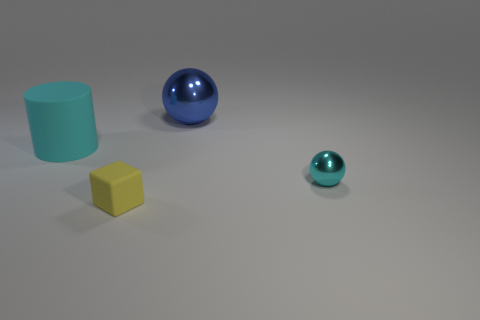There is a object that is right of the yellow rubber object and in front of the big shiny ball; how big is it?
Provide a succinct answer. Small. There is a tiny thing that is right of the large ball; is it the same shape as the big metal object?
Ensure brevity in your answer.  Yes. There is a metal thing that is on the left side of the shiny thing to the right of the metallic object that is behind the matte cylinder; what size is it?
Give a very brief answer. Large. There is a metal thing that is the same color as the large rubber thing; what is its size?
Offer a very short reply. Small. How many objects are yellow metal balls or big cyan matte objects?
Make the answer very short. 1. The object that is behind the small shiny sphere and right of the cyan rubber thing has what shape?
Offer a terse response. Sphere. There is a blue thing; does it have the same shape as the cyan object that is behind the tiny cyan ball?
Your response must be concise. No. Are there any tiny things on the right side of the large cylinder?
Keep it short and to the point. Yes. What material is the small object that is the same color as the large matte cylinder?
Keep it short and to the point. Metal. What number of blocks are cyan things or small cyan metal things?
Offer a very short reply. 0. 